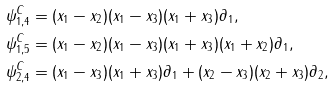Convert formula to latex. <formula><loc_0><loc_0><loc_500><loc_500>\psi ^ { C } _ { 1 , 4 } & = ( x _ { 1 } - x _ { 2 } ) ( x _ { 1 } - x _ { 3 } ) ( x _ { 1 } + x _ { 3 } ) \partial _ { 1 } , \\ \psi ^ { C } _ { 1 , 5 } & = ( x _ { 1 } - x _ { 2 } ) ( x _ { 1 } - x _ { 3 } ) ( x _ { 1 } + x _ { 3 } ) ( x _ { 1 } + x _ { 2 } ) \partial _ { 1 } , \\ \psi ^ { C } _ { 2 , 4 } & = ( x _ { 1 } - x _ { 3 } ) ( x _ { 1 } + x _ { 3 } ) \partial _ { 1 } + ( x _ { 2 } - x _ { 3 } ) ( x _ { 2 } + x _ { 3 } ) \partial _ { 2 } ,</formula> 